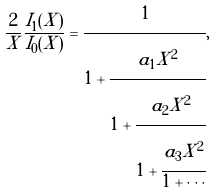<formula> <loc_0><loc_0><loc_500><loc_500>\frac { 2 } { X } \frac { I _ { 1 } ( X ) } { I _ { 0 } ( X ) } = \cfrac { 1 } { 1 + \cfrac { a _ { 1 } X ^ { 2 } } { 1 + \cfrac { a _ { 2 } X ^ { 2 } } { 1 + \cfrac { a _ { 3 } X ^ { 2 } } { 1 + \cdots } } } } ,</formula> 